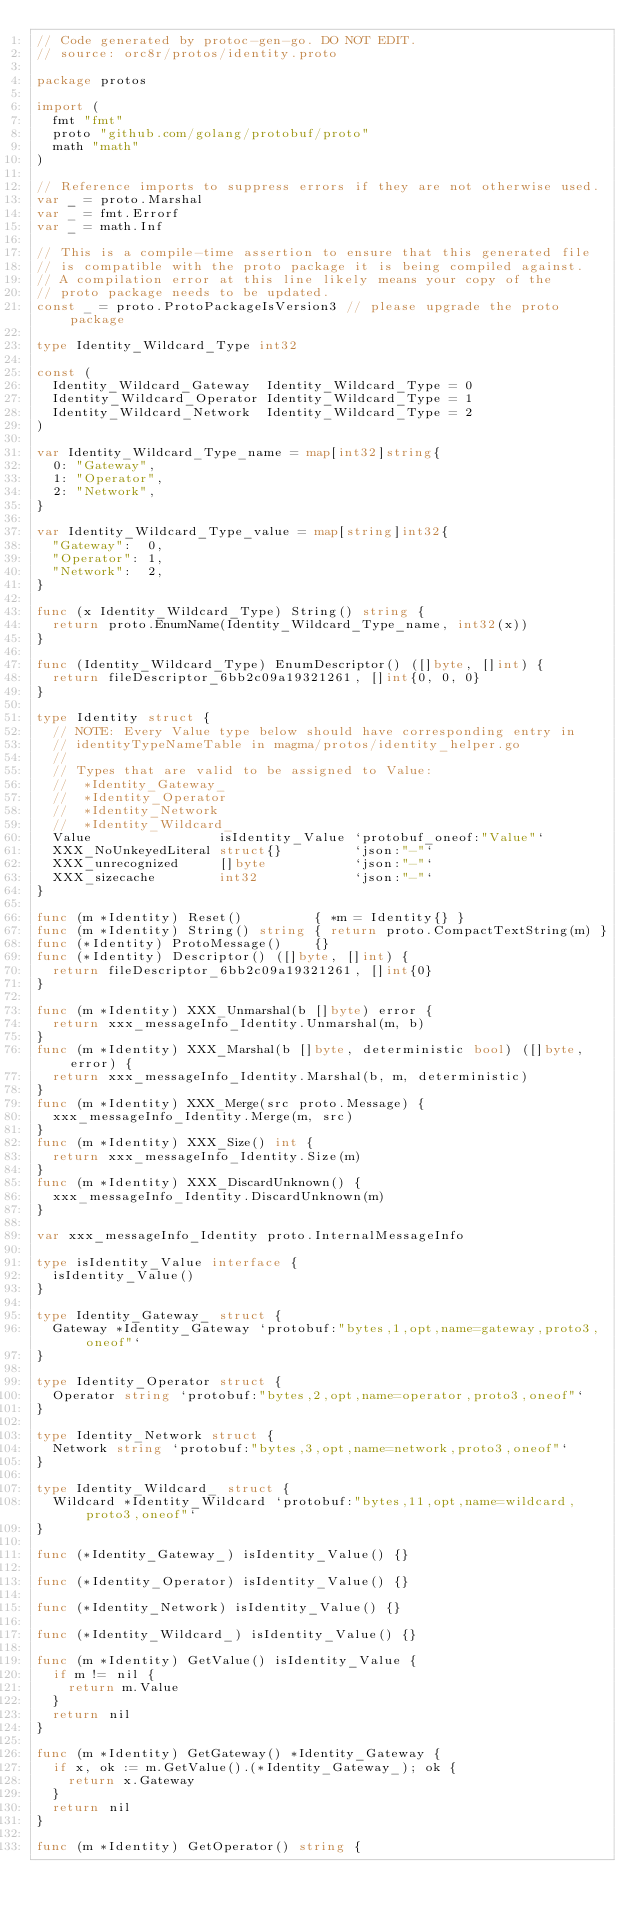Convert code to text. <code><loc_0><loc_0><loc_500><loc_500><_Go_>// Code generated by protoc-gen-go. DO NOT EDIT.
// source: orc8r/protos/identity.proto

package protos

import (
	fmt "fmt"
	proto "github.com/golang/protobuf/proto"
	math "math"
)

// Reference imports to suppress errors if they are not otherwise used.
var _ = proto.Marshal
var _ = fmt.Errorf
var _ = math.Inf

// This is a compile-time assertion to ensure that this generated file
// is compatible with the proto package it is being compiled against.
// A compilation error at this line likely means your copy of the
// proto package needs to be updated.
const _ = proto.ProtoPackageIsVersion3 // please upgrade the proto package

type Identity_Wildcard_Type int32

const (
	Identity_Wildcard_Gateway  Identity_Wildcard_Type = 0
	Identity_Wildcard_Operator Identity_Wildcard_Type = 1
	Identity_Wildcard_Network  Identity_Wildcard_Type = 2
)

var Identity_Wildcard_Type_name = map[int32]string{
	0: "Gateway",
	1: "Operator",
	2: "Network",
}

var Identity_Wildcard_Type_value = map[string]int32{
	"Gateway":  0,
	"Operator": 1,
	"Network":  2,
}

func (x Identity_Wildcard_Type) String() string {
	return proto.EnumName(Identity_Wildcard_Type_name, int32(x))
}

func (Identity_Wildcard_Type) EnumDescriptor() ([]byte, []int) {
	return fileDescriptor_6bb2c09a19321261, []int{0, 0, 0}
}

type Identity struct {
	// NOTE: Every Value type below should have corresponding entry in
	// identityTypeNameTable in magma/protos/identity_helper.go
	//
	// Types that are valid to be assigned to Value:
	//	*Identity_Gateway_
	//	*Identity_Operator
	//	*Identity_Network
	//	*Identity_Wildcard_
	Value                isIdentity_Value `protobuf_oneof:"Value"`
	XXX_NoUnkeyedLiteral struct{}         `json:"-"`
	XXX_unrecognized     []byte           `json:"-"`
	XXX_sizecache        int32            `json:"-"`
}

func (m *Identity) Reset()         { *m = Identity{} }
func (m *Identity) String() string { return proto.CompactTextString(m) }
func (*Identity) ProtoMessage()    {}
func (*Identity) Descriptor() ([]byte, []int) {
	return fileDescriptor_6bb2c09a19321261, []int{0}
}

func (m *Identity) XXX_Unmarshal(b []byte) error {
	return xxx_messageInfo_Identity.Unmarshal(m, b)
}
func (m *Identity) XXX_Marshal(b []byte, deterministic bool) ([]byte, error) {
	return xxx_messageInfo_Identity.Marshal(b, m, deterministic)
}
func (m *Identity) XXX_Merge(src proto.Message) {
	xxx_messageInfo_Identity.Merge(m, src)
}
func (m *Identity) XXX_Size() int {
	return xxx_messageInfo_Identity.Size(m)
}
func (m *Identity) XXX_DiscardUnknown() {
	xxx_messageInfo_Identity.DiscardUnknown(m)
}

var xxx_messageInfo_Identity proto.InternalMessageInfo

type isIdentity_Value interface {
	isIdentity_Value()
}

type Identity_Gateway_ struct {
	Gateway *Identity_Gateway `protobuf:"bytes,1,opt,name=gateway,proto3,oneof"`
}

type Identity_Operator struct {
	Operator string `protobuf:"bytes,2,opt,name=operator,proto3,oneof"`
}

type Identity_Network struct {
	Network string `protobuf:"bytes,3,opt,name=network,proto3,oneof"`
}

type Identity_Wildcard_ struct {
	Wildcard *Identity_Wildcard `protobuf:"bytes,11,opt,name=wildcard,proto3,oneof"`
}

func (*Identity_Gateway_) isIdentity_Value() {}

func (*Identity_Operator) isIdentity_Value() {}

func (*Identity_Network) isIdentity_Value() {}

func (*Identity_Wildcard_) isIdentity_Value() {}

func (m *Identity) GetValue() isIdentity_Value {
	if m != nil {
		return m.Value
	}
	return nil
}

func (m *Identity) GetGateway() *Identity_Gateway {
	if x, ok := m.GetValue().(*Identity_Gateway_); ok {
		return x.Gateway
	}
	return nil
}

func (m *Identity) GetOperator() string {</code> 